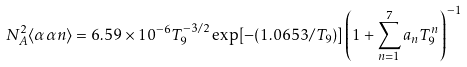Convert formula to latex. <formula><loc_0><loc_0><loc_500><loc_500>N _ { A } ^ { 2 } \langle \alpha \alpha n \rangle = 6 . 5 9 \times 1 0 ^ { - 6 } T _ { 9 } ^ { - 3 / 2 } \exp [ - ( 1 . 0 6 5 3 / T _ { 9 } ) ] \left ( 1 + \sum _ { n = 1 } ^ { 7 } a _ { n } T _ { 9 } ^ { n } \right ) ^ { - 1 }</formula> 